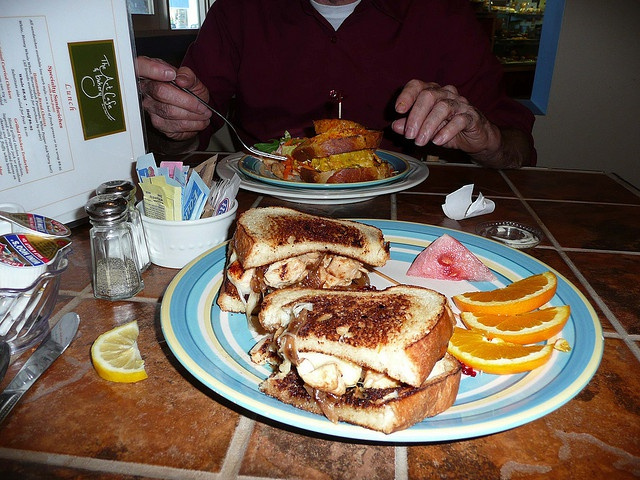Describe the objects in this image and their specific colors. I can see dining table in gray, black, maroon, and brown tones, people in gray, black, maroon, and brown tones, sandwich in gray, beige, tan, and maroon tones, sandwich in gray, maroon, tan, and brown tones, and bowl in gray, maroon, black, and olive tones in this image. 